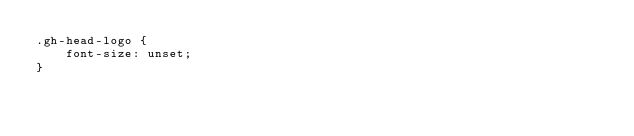<code> <loc_0><loc_0><loc_500><loc_500><_CSS_>.gh-head-logo {
    font-size: unset;
}</code> 